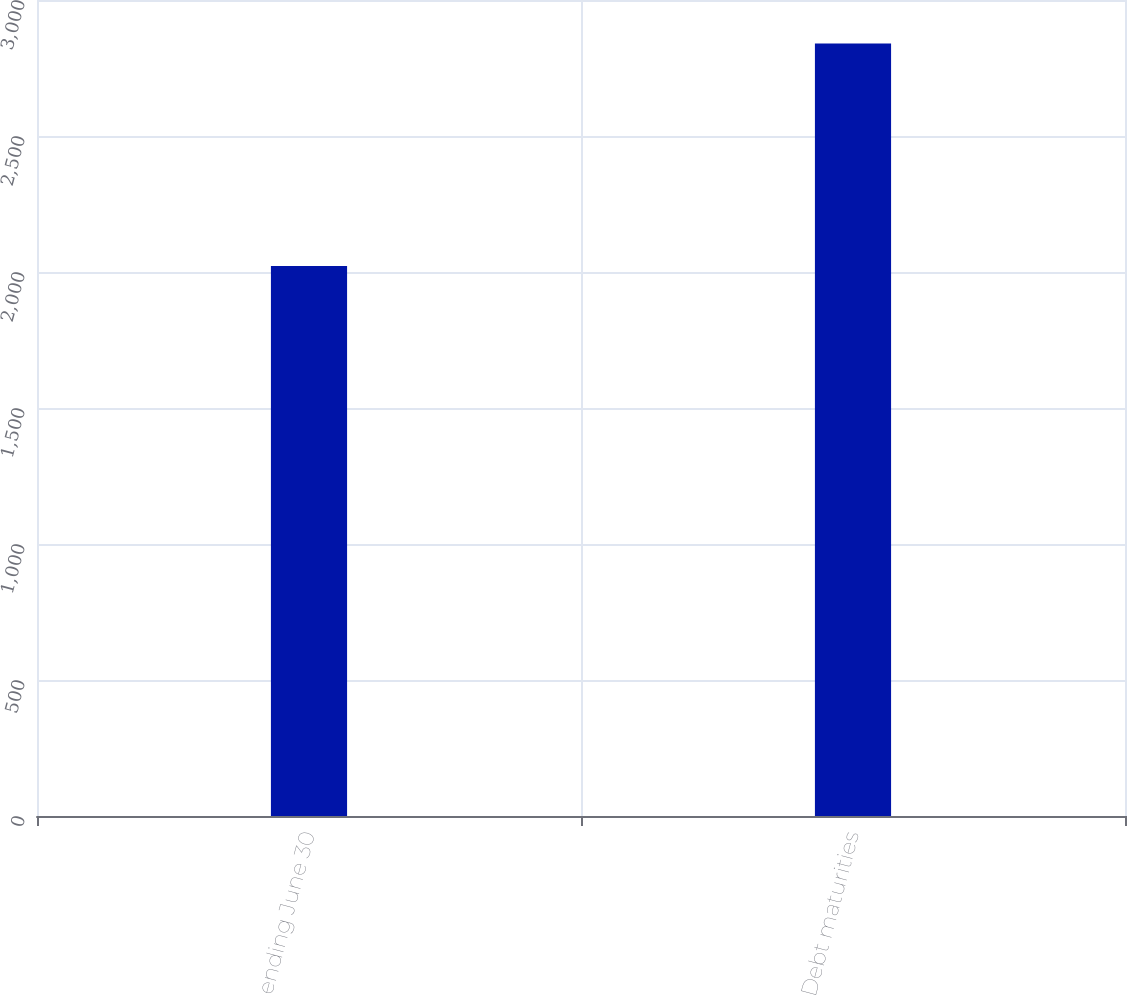Convert chart to OTSL. <chart><loc_0><loc_0><loc_500><loc_500><bar_chart><fcel>Years ending June 30<fcel>Debt maturities<nl><fcel>2022<fcel>2840<nl></chart> 